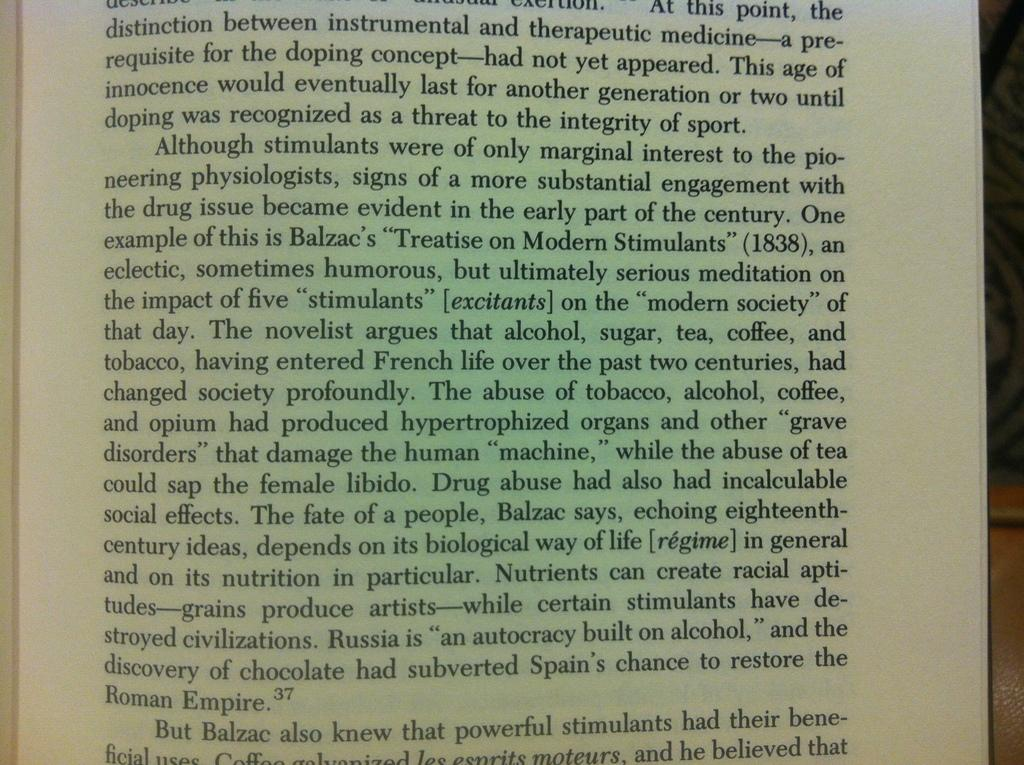<image>
Summarize the visual content of the image. Distinction is the first word visible on an open page of text. 